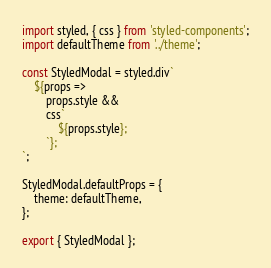Convert code to text. <code><loc_0><loc_0><loc_500><loc_500><_JavaScript_>import styled, { css } from 'styled-components';
import defaultTheme from '../theme';

const StyledModal = styled.div`
    ${props =>
        props.style &&
        css`
            ${props.style};
        `};
`;

StyledModal.defaultProps = {
    theme: defaultTheme,
};

export { StyledModal };
</code> 